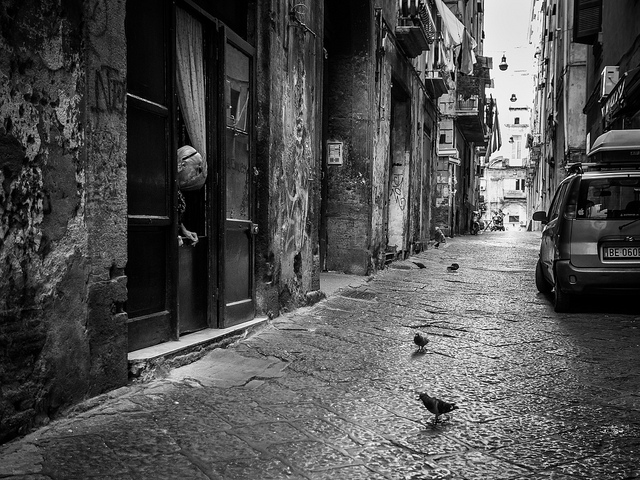Identify the text displayed in this image. BE 050 NE 